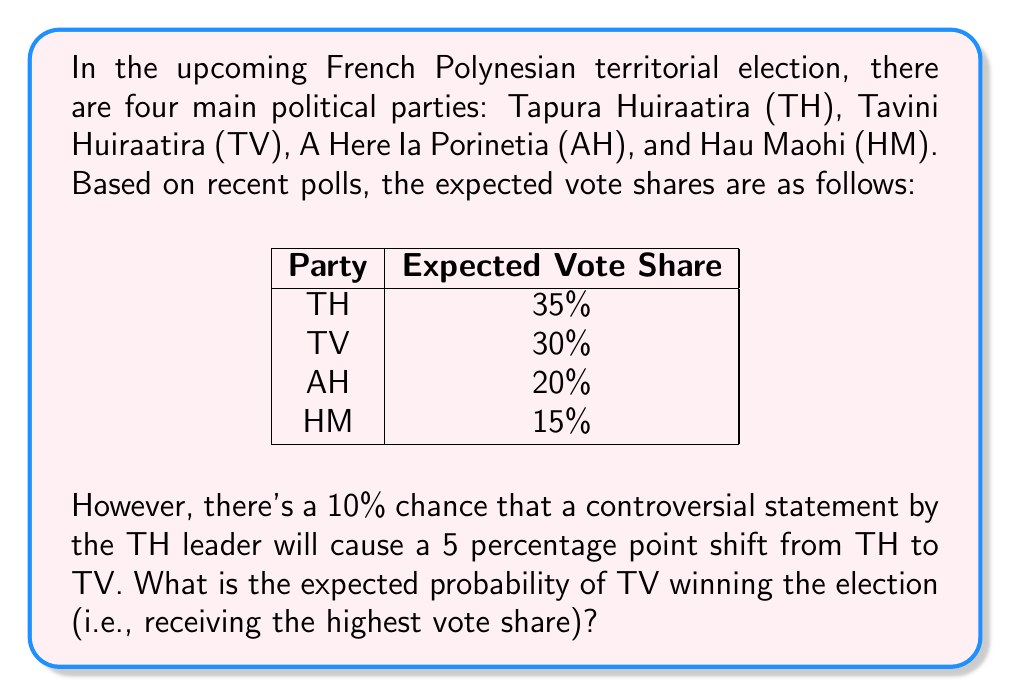Can you solve this math problem? Let's approach this step-by-step:

1) First, we need to calculate the probability of TV winning without the controversial statement:
   In this case, TH has the highest vote share at 35%, so TV doesn't win.
   Probability = 0

2) Now, let's calculate the probability of TV winning if the controversial statement occurs:
   If the statement occurs, the new vote shares would be:
   TH: 30% (35% - 5%)
   TV: 35% (30% + 5%)
   AH: 20%
   HM: 15%
   
   In this case, TV would have the highest vote share and win.
   Probability = 1

3) To calculate the expected probability, we use the formula for expected value:
   $$E(X) = \sum_{i=1}^{n} p_i x_i$$
   
   Where:
   $p_i$ is the probability of each outcome
   $x_i$ is the value of each outcome

4) In our case:
   Probability of no controversial statement: 90% (0.9)
   Probability of controversial statement: 10% (0.1)

   $$E(\text{TV winning}) = 0.9 \cdot 0 + 0.1 \cdot 1 = 0.1$$

Therefore, the expected probability of TV winning the election is 0.1 or 10%.
Answer: 0.1 